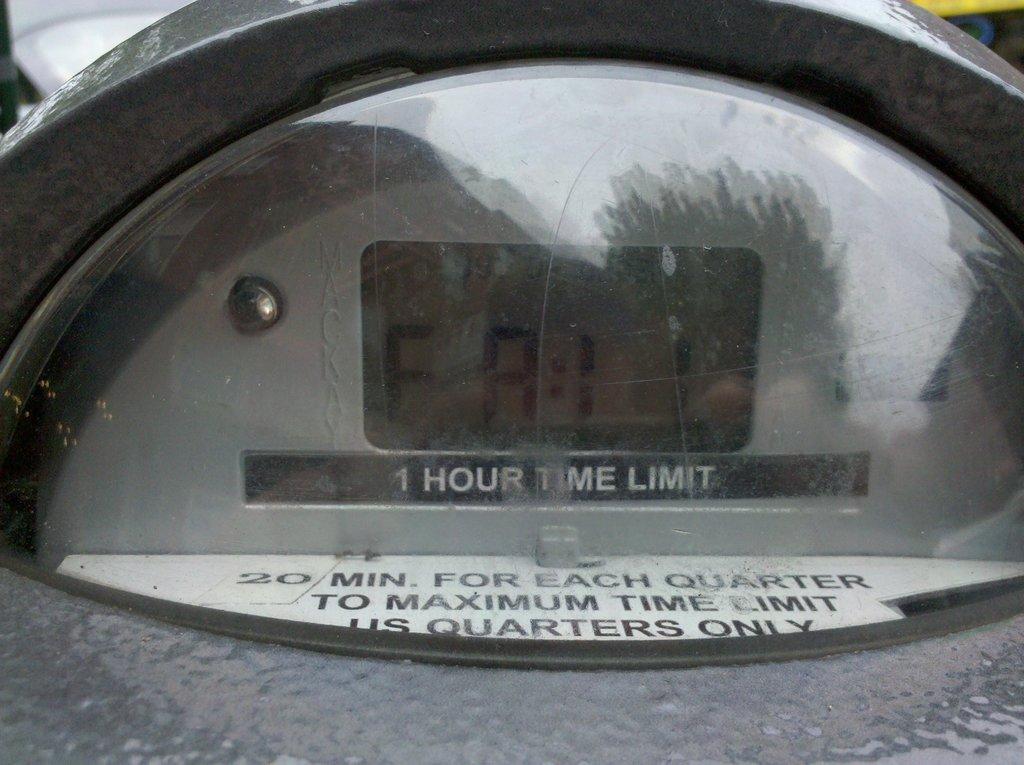What is the time limit?
Your answer should be very brief. 1 hour. What is the maximum time limit?
Make the answer very short. 1 hour. 